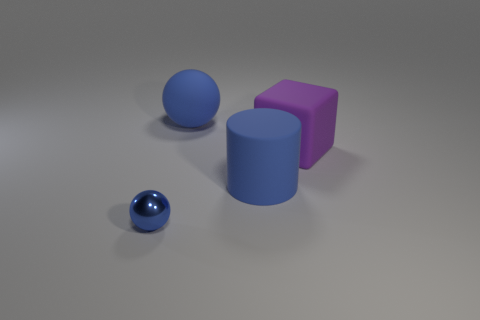What number of things are both to the left of the large purple rubber thing and on the right side of the tiny sphere?
Offer a very short reply. 2. The cylinder is what color?
Provide a short and direct response. Blue. There is another blue object that is the same shape as the tiny metal thing; what material is it?
Your response must be concise. Rubber. Are there any other things that have the same material as the big ball?
Your answer should be very brief. Yes. Do the big rubber sphere and the cylinder have the same color?
Provide a short and direct response. Yes. There is a blue matte object in front of the blue rubber object that is on the left side of the blue matte cylinder; what shape is it?
Ensure brevity in your answer.  Cylinder. There is a purple thing that is made of the same material as the blue cylinder; what shape is it?
Ensure brevity in your answer.  Cube. What number of other objects are there of the same shape as the purple matte thing?
Make the answer very short. 0. Is the size of the rubber thing that is to the left of the blue cylinder the same as the large blue rubber cylinder?
Make the answer very short. Yes. Are there more tiny blue balls that are behind the big purple matte block than purple metal cylinders?
Your answer should be compact. No. 